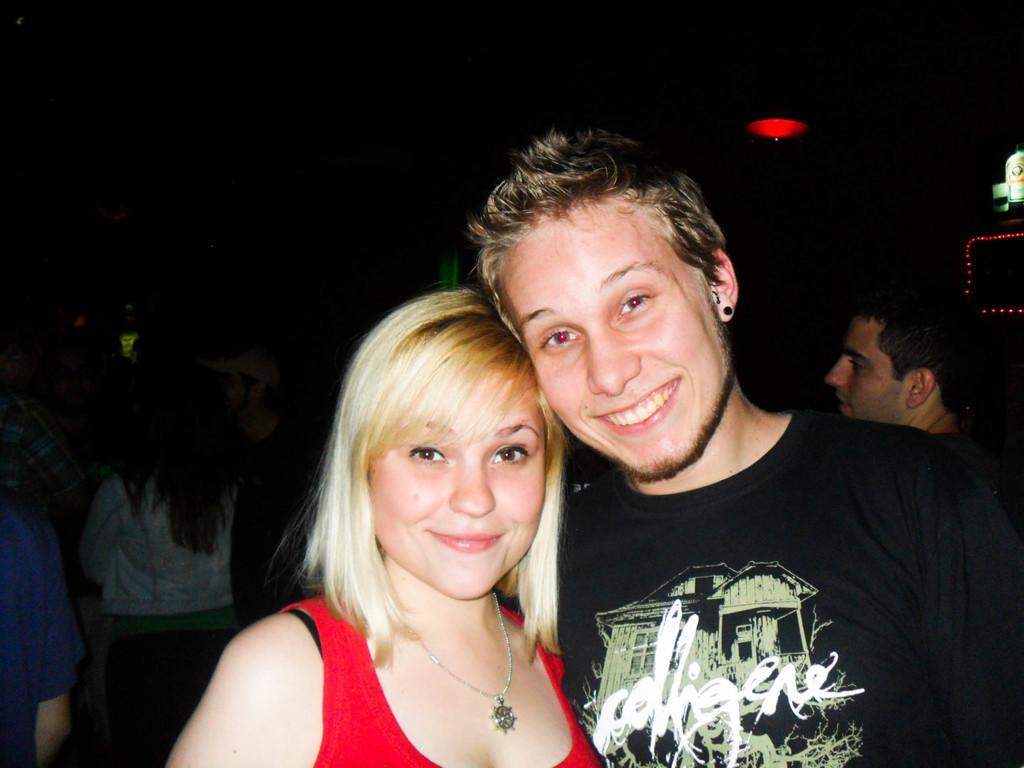How would you summarize this image in a sentence or two? There is a couple in the picture posing for a photograph. The right side one is man and the left side one is female. The man is wearing a black t shirt and a stud to his ear. Both of them are smiling. The woman is wearing a red racer. She is wearing a chain. Her hair is yellow in colour. Behind them some of them are standing in the dark. One is the guy is wearing the cap. In the background there is a red light. 